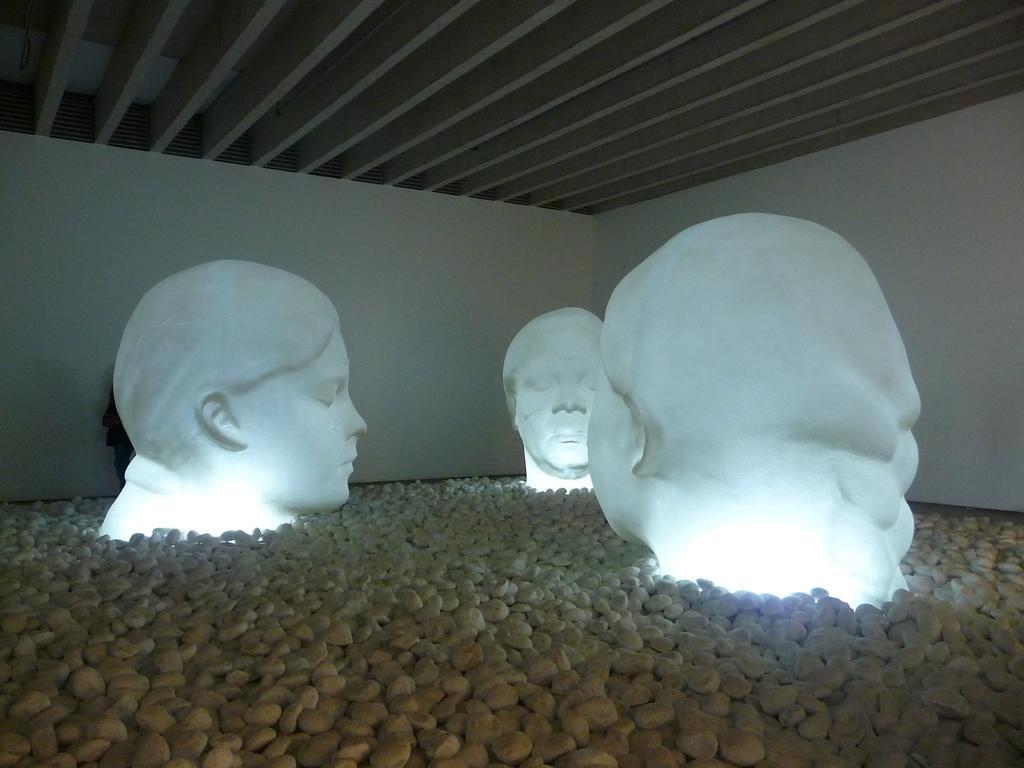How would you summarize this image in a sentence or two? In this picture we can see there are sculptures heads on the stones. At the top of the image, there is a ceiling. 